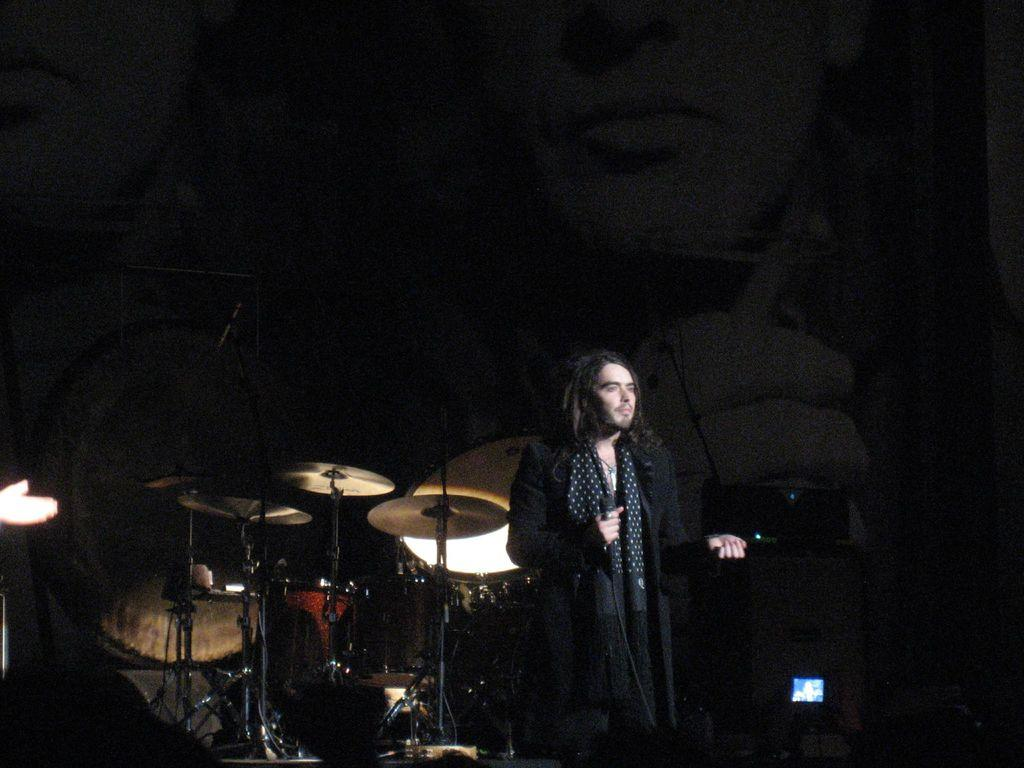Who or what is present in the image? There are people in the image. What are the people doing in the image? The people are playing musical instruments in the image. What can be observed about the background of the image? The background of the image is dark. What type of crime is being committed in the image? There is no crime being committed in the image; it features people playing musical instruments. How many groups of people are playing musical instruments in the image? There is no mention of multiple groups of people in the image; it only mentions that there are people playing musical instruments. 